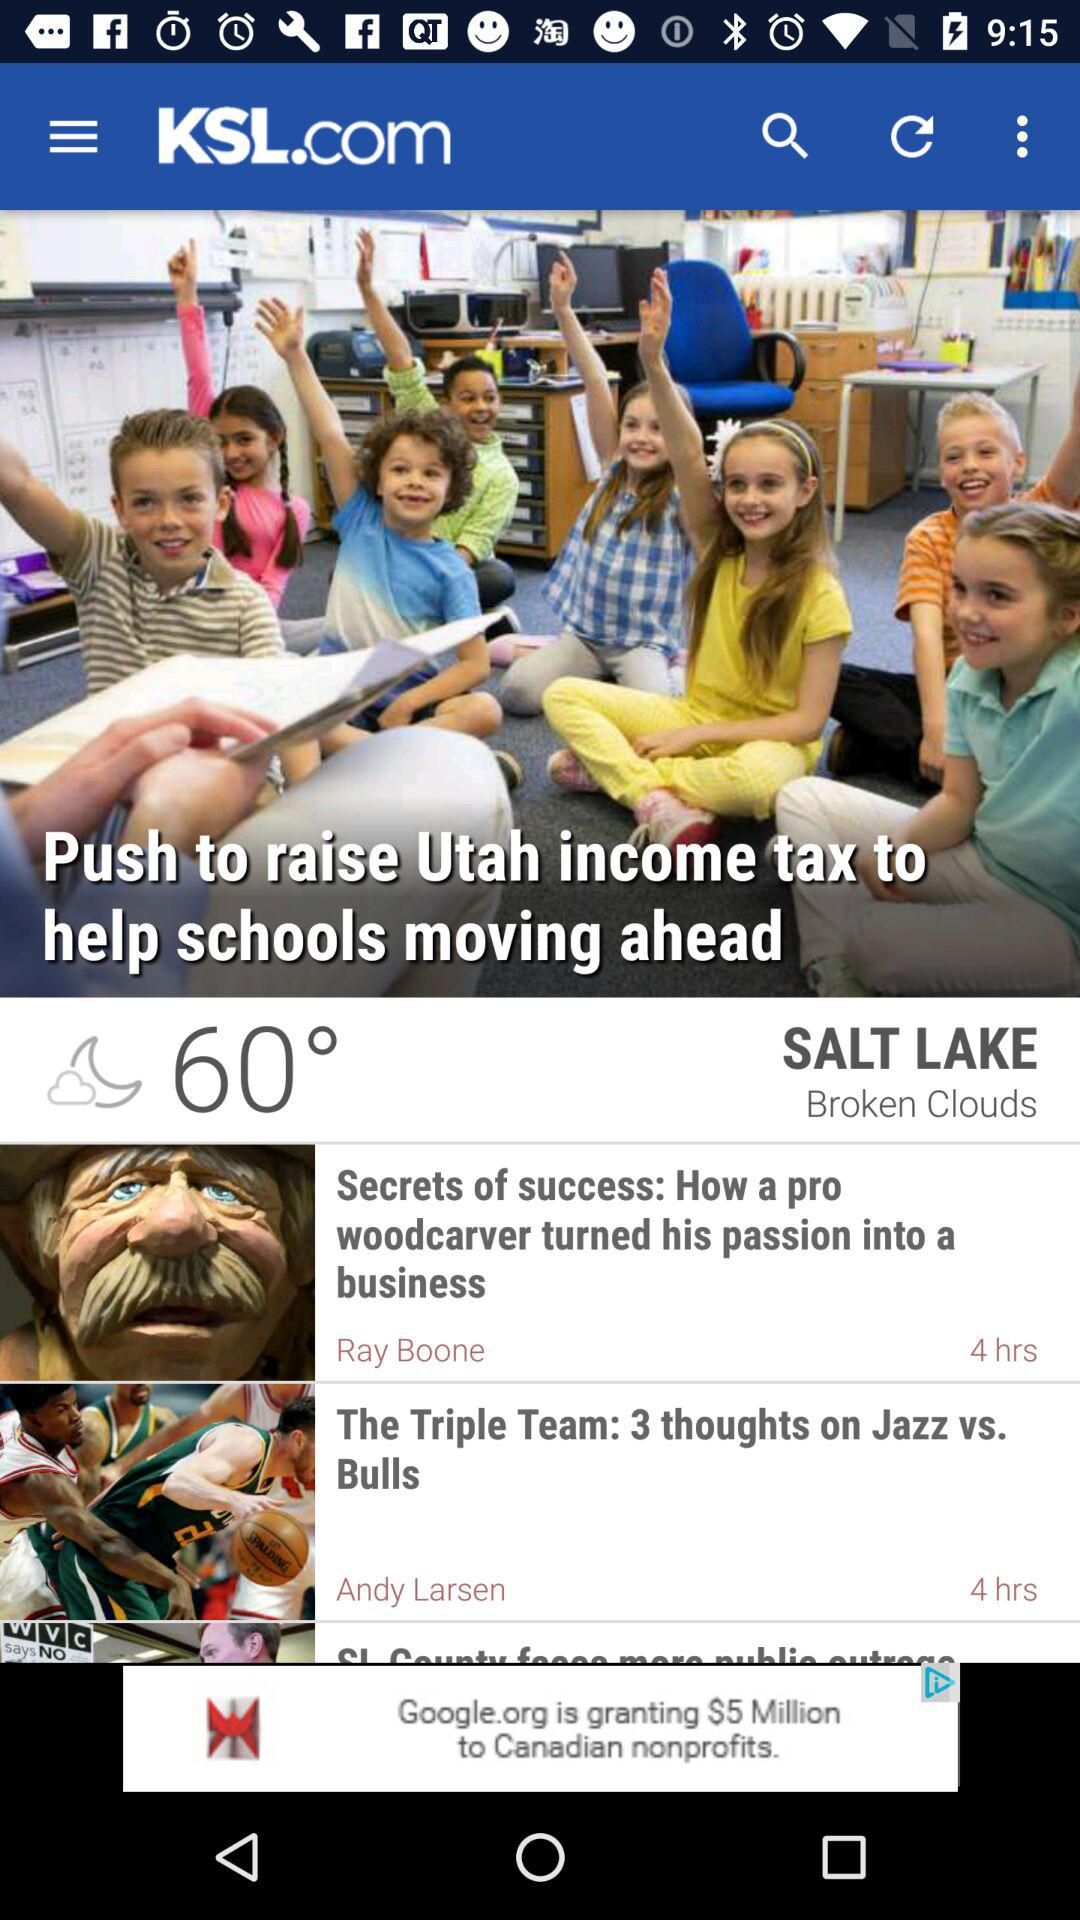What is the temperature? The temperature is 60 degrees. 